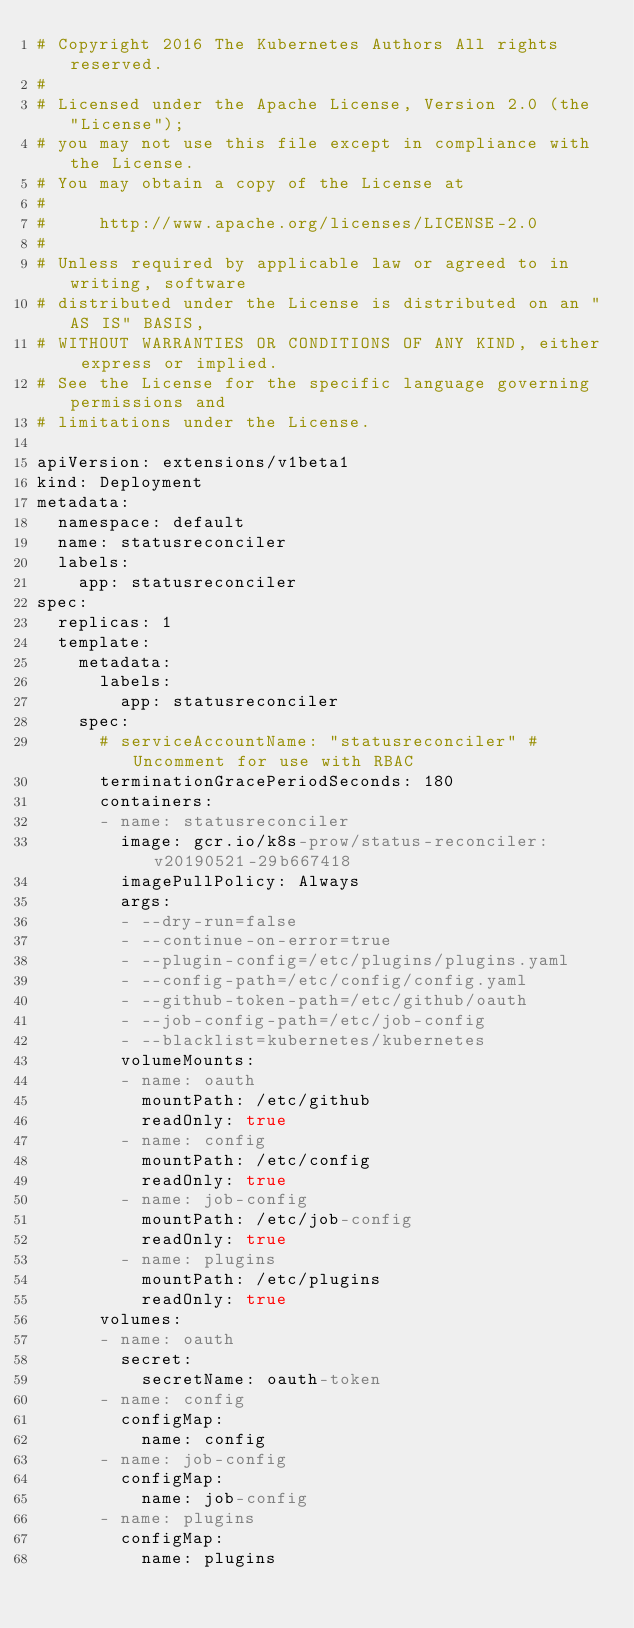<code> <loc_0><loc_0><loc_500><loc_500><_YAML_># Copyright 2016 The Kubernetes Authors All rights reserved.
#
# Licensed under the Apache License, Version 2.0 (the "License");
# you may not use this file except in compliance with the License.
# You may obtain a copy of the License at
#
#     http://www.apache.org/licenses/LICENSE-2.0
#
# Unless required by applicable law or agreed to in writing, software
# distributed under the License is distributed on an "AS IS" BASIS,
# WITHOUT WARRANTIES OR CONDITIONS OF ANY KIND, either express or implied.
# See the License for the specific language governing permissions and
# limitations under the License.

apiVersion: extensions/v1beta1
kind: Deployment
metadata:
  namespace: default
  name: statusreconciler
  labels:
    app: statusreconciler
spec:
  replicas: 1
  template:
    metadata:
      labels:
        app: statusreconciler
    spec:
      # serviceAccountName: "statusreconciler" # Uncomment for use with RBAC
      terminationGracePeriodSeconds: 180
      containers:
      - name: statusreconciler
        image: gcr.io/k8s-prow/status-reconciler:v20190521-29b667418
        imagePullPolicy: Always
        args:
        - --dry-run=false
        - --continue-on-error=true
        - --plugin-config=/etc/plugins/plugins.yaml
        - --config-path=/etc/config/config.yaml
        - --github-token-path=/etc/github/oauth
        - --job-config-path=/etc/job-config
        - --blacklist=kubernetes/kubernetes
        volumeMounts:
        - name: oauth
          mountPath: /etc/github
          readOnly: true
        - name: config
          mountPath: /etc/config
          readOnly: true
        - name: job-config
          mountPath: /etc/job-config
          readOnly: true
        - name: plugins
          mountPath: /etc/plugins
          readOnly: true
      volumes:
      - name: oauth
        secret:
          secretName: oauth-token
      - name: config
        configMap:
          name: config
      - name: job-config
        configMap:
          name: job-config
      - name: plugins
        configMap:
          name: plugins
</code> 